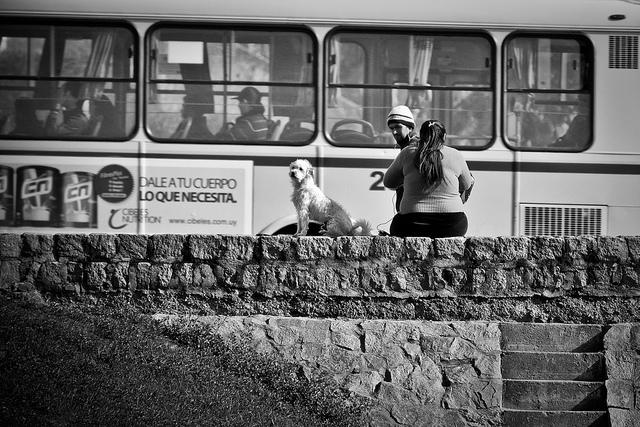Is the Dog waiting for the bus?
Short answer required. No. How many people are not in the bus?
Short answer required. 2. Who owns the dog?
Give a very brief answer. Woman. 